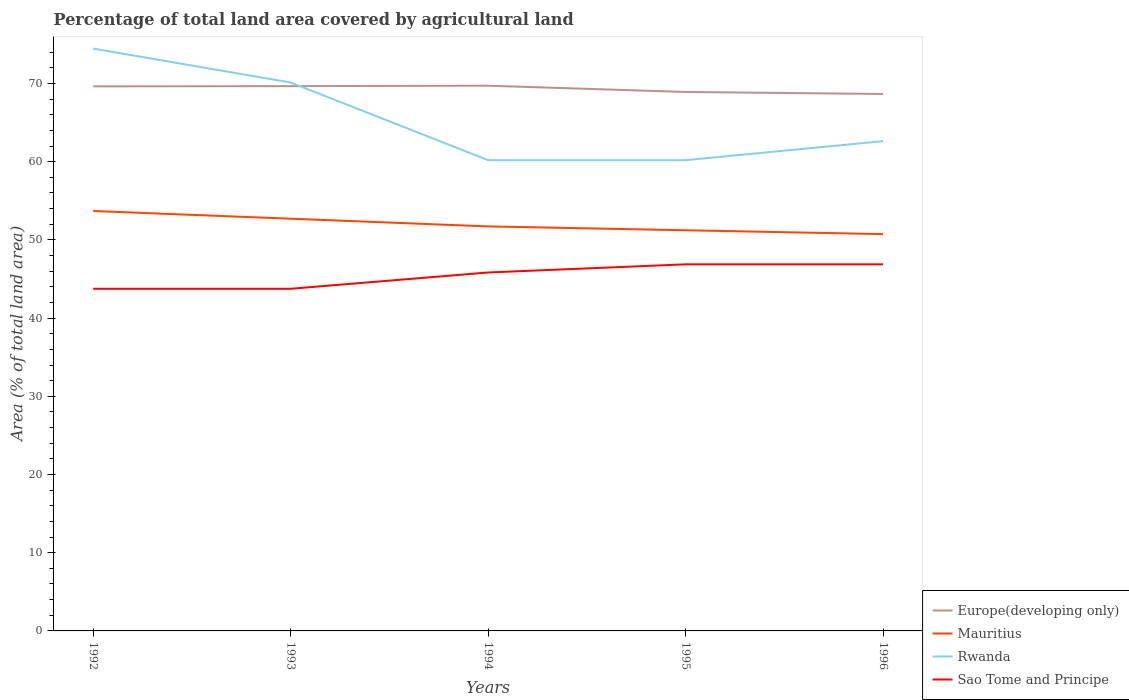Is the number of lines equal to the number of legend labels?
Give a very brief answer. Yes. Across all years, what is the maximum percentage of agricultural land in Mauritius?
Your answer should be very brief. 50.74. What is the total percentage of agricultural land in Rwanda in the graph?
Make the answer very short. 9.93. What is the difference between the highest and the second highest percentage of agricultural land in Mauritius?
Provide a short and direct response. 2.96. What is the difference between the highest and the lowest percentage of agricultural land in Sao Tome and Principe?
Offer a very short reply. 3. What is the difference between two consecutive major ticks on the Y-axis?
Offer a very short reply. 10. Are the values on the major ticks of Y-axis written in scientific E-notation?
Give a very brief answer. No. Does the graph contain any zero values?
Ensure brevity in your answer.  No. Does the graph contain grids?
Offer a very short reply. No. How many legend labels are there?
Your answer should be very brief. 4. What is the title of the graph?
Your answer should be very brief. Percentage of total land area covered by agricultural land. Does "Germany" appear as one of the legend labels in the graph?
Keep it short and to the point. No. What is the label or title of the X-axis?
Provide a short and direct response. Years. What is the label or title of the Y-axis?
Ensure brevity in your answer.  Area (% of total land area). What is the Area (% of total land area) of Europe(developing only) in 1992?
Provide a short and direct response. 69.63. What is the Area (% of total land area) in Mauritius in 1992?
Offer a terse response. 53.69. What is the Area (% of total land area) in Rwanda in 1992?
Make the answer very short. 74.46. What is the Area (% of total land area) in Sao Tome and Principe in 1992?
Give a very brief answer. 43.75. What is the Area (% of total land area) of Europe(developing only) in 1993?
Keep it short and to the point. 69.66. What is the Area (% of total land area) of Mauritius in 1993?
Offer a terse response. 52.71. What is the Area (% of total land area) of Rwanda in 1993?
Offer a terse response. 70.13. What is the Area (% of total land area) of Sao Tome and Principe in 1993?
Give a very brief answer. 43.75. What is the Area (% of total land area) of Europe(developing only) in 1994?
Provide a short and direct response. 69.72. What is the Area (% of total land area) in Mauritius in 1994?
Provide a short and direct response. 51.72. What is the Area (% of total land area) of Rwanda in 1994?
Offer a terse response. 60.19. What is the Area (% of total land area) in Sao Tome and Principe in 1994?
Make the answer very short. 45.83. What is the Area (% of total land area) of Europe(developing only) in 1995?
Provide a succinct answer. 68.92. What is the Area (% of total land area) of Mauritius in 1995?
Your response must be concise. 51.23. What is the Area (% of total land area) in Rwanda in 1995?
Keep it short and to the point. 60.19. What is the Area (% of total land area) in Sao Tome and Principe in 1995?
Your answer should be compact. 46.88. What is the Area (% of total land area) in Europe(developing only) in 1996?
Keep it short and to the point. 68.66. What is the Area (% of total land area) in Mauritius in 1996?
Provide a succinct answer. 50.74. What is the Area (% of total land area) of Rwanda in 1996?
Offer a terse response. 62.63. What is the Area (% of total land area) in Sao Tome and Principe in 1996?
Provide a succinct answer. 46.88. Across all years, what is the maximum Area (% of total land area) of Europe(developing only)?
Provide a short and direct response. 69.72. Across all years, what is the maximum Area (% of total land area) in Mauritius?
Give a very brief answer. 53.69. Across all years, what is the maximum Area (% of total land area) in Rwanda?
Give a very brief answer. 74.46. Across all years, what is the maximum Area (% of total land area) in Sao Tome and Principe?
Your answer should be very brief. 46.88. Across all years, what is the minimum Area (% of total land area) in Europe(developing only)?
Ensure brevity in your answer.  68.66. Across all years, what is the minimum Area (% of total land area) of Mauritius?
Keep it short and to the point. 50.74. Across all years, what is the minimum Area (% of total land area) in Rwanda?
Your answer should be very brief. 60.19. Across all years, what is the minimum Area (% of total land area) in Sao Tome and Principe?
Offer a terse response. 43.75. What is the total Area (% of total land area) of Europe(developing only) in the graph?
Provide a succinct answer. 346.58. What is the total Area (% of total land area) of Mauritius in the graph?
Provide a short and direct response. 260.1. What is the total Area (% of total land area) of Rwanda in the graph?
Your answer should be compact. 327.6. What is the total Area (% of total land area) of Sao Tome and Principe in the graph?
Provide a succinct answer. 227.08. What is the difference between the Area (% of total land area) in Europe(developing only) in 1992 and that in 1993?
Give a very brief answer. -0.03. What is the difference between the Area (% of total land area) of Mauritius in 1992 and that in 1993?
Provide a succinct answer. 0.99. What is the difference between the Area (% of total land area) in Rwanda in 1992 and that in 1993?
Offer a very short reply. 4.34. What is the difference between the Area (% of total land area) in Europe(developing only) in 1992 and that in 1994?
Provide a succinct answer. -0.08. What is the difference between the Area (% of total land area) of Mauritius in 1992 and that in 1994?
Your answer should be very brief. 1.97. What is the difference between the Area (% of total land area) of Rwanda in 1992 and that in 1994?
Offer a terse response. 14.27. What is the difference between the Area (% of total land area) in Sao Tome and Principe in 1992 and that in 1994?
Give a very brief answer. -2.08. What is the difference between the Area (% of total land area) in Europe(developing only) in 1992 and that in 1995?
Make the answer very short. 0.72. What is the difference between the Area (% of total land area) in Mauritius in 1992 and that in 1995?
Give a very brief answer. 2.46. What is the difference between the Area (% of total land area) of Rwanda in 1992 and that in 1995?
Your response must be concise. 14.27. What is the difference between the Area (% of total land area) in Sao Tome and Principe in 1992 and that in 1995?
Keep it short and to the point. -3.12. What is the difference between the Area (% of total land area) of Mauritius in 1992 and that in 1996?
Offer a very short reply. 2.96. What is the difference between the Area (% of total land area) of Rwanda in 1992 and that in 1996?
Your answer should be compact. 11.84. What is the difference between the Area (% of total land area) in Sao Tome and Principe in 1992 and that in 1996?
Your answer should be compact. -3.12. What is the difference between the Area (% of total land area) of Europe(developing only) in 1993 and that in 1994?
Provide a short and direct response. -0.05. What is the difference between the Area (% of total land area) in Mauritius in 1993 and that in 1994?
Ensure brevity in your answer.  0.99. What is the difference between the Area (% of total land area) in Rwanda in 1993 and that in 1994?
Keep it short and to the point. 9.93. What is the difference between the Area (% of total land area) in Sao Tome and Principe in 1993 and that in 1994?
Your answer should be very brief. -2.08. What is the difference between the Area (% of total land area) in Europe(developing only) in 1993 and that in 1995?
Provide a short and direct response. 0.75. What is the difference between the Area (% of total land area) of Mauritius in 1993 and that in 1995?
Ensure brevity in your answer.  1.48. What is the difference between the Area (% of total land area) of Rwanda in 1993 and that in 1995?
Your answer should be very brief. 9.93. What is the difference between the Area (% of total land area) of Sao Tome and Principe in 1993 and that in 1995?
Your answer should be compact. -3.12. What is the difference between the Area (% of total land area) of Europe(developing only) in 1993 and that in 1996?
Offer a very short reply. 1.01. What is the difference between the Area (% of total land area) in Mauritius in 1993 and that in 1996?
Make the answer very short. 1.97. What is the difference between the Area (% of total land area) in Rwanda in 1993 and that in 1996?
Your answer should be compact. 7.5. What is the difference between the Area (% of total land area) in Sao Tome and Principe in 1993 and that in 1996?
Your answer should be very brief. -3.12. What is the difference between the Area (% of total land area) of Europe(developing only) in 1994 and that in 1995?
Provide a short and direct response. 0.8. What is the difference between the Area (% of total land area) in Mauritius in 1994 and that in 1995?
Your response must be concise. 0.49. What is the difference between the Area (% of total land area) of Rwanda in 1994 and that in 1995?
Offer a very short reply. 0. What is the difference between the Area (% of total land area) in Sao Tome and Principe in 1994 and that in 1995?
Your answer should be very brief. -1.04. What is the difference between the Area (% of total land area) of Europe(developing only) in 1994 and that in 1996?
Give a very brief answer. 1.06. What is the difference between the Area (% of total land area) in Mauritius in 1994 and that in 1996?
Make the answer very short. 0.99. What is the difference between the Area (% of total land area) in Rwanda in 1994 and that in 1996?
Offer a very short reply. -2.43. What is the difference between the Area (% of total land area) in Sao Tome and Principe in 1994 and that in 1996?
Offer a very short reply. -1.04. What is the difference between the Area (% of total land area) in Europe(developing only) in 1995 and that in 1996?
Provide a succinct answer. 0.26. What is the difference between the Area (% of total land area) of Mauritius in 1995 and that in 1996?
Offer a terse response. 0.49. What is the difference between the Area (% of total land area) in Rwanda in 1995 and that in 1996?
Make the answer very short. -2.43. What is the difference between the Area (% of total land area) in Europe(developing only) in 1992 and the Area (% of total land area) in Mauritius in 1993?
Your answer should be very brief. 16.92. What is the difference between the Area (% of total land area) in Europe(developing only) in 1992 and the Area (% of total land area) in Rwanda in 1993?
Your answer should be compact. -0.49. What is the difference between the Area (% of total land area) in Europe(developing only) in 1992 and the Area (% of total land area) in Sao Tome and Principe in 1993?
Give a very brief answer. 25.88. What is the difference between the Area (% of total land area) in Mauritius in 1992 and the Area (% of total land area) in Rwanda in 1993?
Keep it short and to the point. -16.43. What is the difference between the Area (% of total land area) of Mauritius in 1992 and the Area (% of total land area) of Sao Tome and Principe in 1993?
Provide a succinct answer. 9.94. What is the difference between the Area (% of total land area) of Rwanda in 1992 and the Area (% of total land area) of Sao Tome and Principe in 1993?
Keep it short and to the point. 30.71. What is the difference between the Area (% of total land area) in Europe(developing only) in 1992 and the Area (% of total land area) in Mauritius in 1994?
Your answer should be compact. 17.91. What is the difference between the Area (% of total land area) of Europe(developing only) in 1992 and the Area (% of total land area) of Rwanda in 1994?
Offer a very short reply. 9.44. What is the difference between the Area (% of total land area) in Europe(developing only) in 1992 and the Area (% of total land area) in Sao Tome and Principe in 1994?
Give a very brief answer. 23.8. What is the difference between the Area (% of total land area) of Mauritius in 1992 and the Area (% of total land area) of Sao Tome and Principe in 1994?
Give a very brief answer. 7.86. What is the difference between the Area (% of total land area) in Rwanda in 1992 and the Area (% of total land area) in Sao Tome and Principe in 1994?
Make the answer very short. 28.63. What is the difference between the Area (% of total land area) of Europe(developing only) in 1992 and the Area (% of total land area) of Mauritius in 1995?
Offer a very short reply. 18.4. What is the difference between the Area (% of total land area) in Europe(developing only) in 1992 and the Area (% of total land area) in Rwanda in 1995?
Your answer should be very brief. 9.44. What is the difference between the Area (% of total land area) of Europe(developing only) in 1992 and the Area (% of total land area) of Sao Tome and Principe in 1995?
Your answer should be compact. 22.76. What is the difference between the Area (% of total land area) in Mauritius in 1992 and the Area (% of total land area) in Sao Tome and Principe in 1995?
Make the answer very short. 6.82. What is the difference between the Area (% of total land area) in Rwanda in 1992 and the Area (% of total land area) in Sao Tome and Principe in 1995?
Provide a succinct answer. 27.59. What is the difference between the Area (% of total land area) of Europe(developing only) in 1992 and the Area (% of total land area) of Mauritius in 1996?
Ensure brevity in your answer.  18.89. What is the difference between the Area (% of total land area) in Europe(developing only) in 1992 and the Area (% of total land area) in Rwanda in 1996?
Offer a terse response. 7.01. What is the difference between the Area (% of total land area) in Europe(developing only) in 1992 and the Area (% of total land area) in Sao Tome and Principe in 1996?
Offer a terse response. 22.76. What is the difference between the Area (% of total land area) of Mauritius in 1992 and the Area (% of total land area) of Rwanda in 1996?
Ensure brevity in your answer.  -8.93. What is the difference between the Area (% of total land area) of Mauritius in 1992 and the Area (% of total land area) of Sao Tome and Principe in 1996?
Give a very brief answer. 6.82. What is the difference between the Area (% of total land area) in Rwanda in 1992 and the Area (% of total land area) in Sao Tome and Principe in 1996?
Offer a very short reply. 27.59. What is the difference between the Area (% of total land area) of Europe(developing only) in 1993 and the Area (% of total land area) of Mauritius in 1994?
Provide a short and direct response. 17.94. What is the difference between the Area (% of total land area) of Europe(developing only) in 1993 and the Area (% of total land area) of Rwanda in 1994?
Your answer should be very brief. 9.47. What is the difference between the Area (% of total land area) in Europe(developing only) in 1993 and the Area (% of total land area) in Sao Tome and Principe in 1994?
Your answer should be very brief. 23.83. What is the difference between the Area (% of total land area) in Mauritius in 1993 and the Area (% of total land area) in Rwanda in 1994?
Offer a terse response. -7.49. What is the difference between the Area (% of total land area) in Mauritius in 1993 and the Area (% of total land area) in Sao Tome and Principe in 1994?
Your answer should be very brief. 6.88. What is the difference between the Area (% of total land area) of Rwanda in 1993 and the Area (% of total land area) of Sao Tome and Principe in 1994?
Your answer should be very brief. 24.29. What is the difference between the Area (% of total land area) in Europe(developing only) in 1993 and the Area (% of total land area) in Mauritius in 1995?
Your answer should be very brief. 18.43. What is the difference between the Area (% of total land area) in Europe(developing only) in 1993 and the Area (% of total land area) in Rwanda in 1995?
Offer a terse response. 9.47. What is the difference between the Area (% of total land area) in Europe(developing only) in 1993 and the Area (% of total land area) in Sao Tome and Principe in 1995?
Offer a very short reply. 22.79. What is the difference between the Area (% of total land area) of Mauritius in 1993 and the Area (% of total land area) of Rwanda in 1995?
Make the answer very short. -7.49. What is the difference between the Area (% of total land area) of Mauritius in 1993 and the Area (% of total land area) of Sao Tome and Principe in 1995?
Your answer should be very brief. 5.83. What is the difference between the Area (% of total land area) of Rwanda in 1993 and the Area (% of total land area) of Sao Tome and Principe in 1995?
Keep it short and to the point. 23.25. What is the difference between the Area (% of total land area) in Europe(developing only) in 1993 and the Area (% of total land area) in Mauritius in 1996?
Keep it short and to the point. 18.92. What is the difference between the Area (% of total land area) in Europe(developing only) in 1993 and the Area (% of total land area) in Rwanda in 1996?
Provide a short and direct response. 7.04. What is the difference between the Area (% of total land area) in Europe(developing only) in 1993 and the Area (% of total land area) in Sao Tome and Principe in 1996?
Give a very brief answer. 22.79. What is the difference between the Area (% of total land area) of Mauritius in 1993 and the Area (% of total land area) of Rwanda in 1996?
Ensure brevity in your answer.  -9.92. What is the difference between the Area (% of total land area) of Mauritius in 1993 and the Area (% of total land area) of Sao Tome and Principe in 1996?
Offer a terse response. 5.83. What is the difference between the Area (% of total land area) in Rwanda in 1993 and the Area (% of total land area) in Sao Tome and Principe in 1996?
Keep it short and to the point. 23.25. What is the difference between the Area (% of total land area) in Europe(developing only) in 1994 and the Area (% of total land area) in Mauritius in 1995?
Offer a very short reply. 18.48. What is the difference between the Area (% of total land area) of Europe(developing only) in 1994 and the Area (% of total land area) of Rwanda in 1995?
Give a very brief answer. 9.52. What is the difference between the Area (% of total land area) of Europe(developing only) in 1994 and the Area (% of total land area) of Sao Tome and Principe in 1995?
Offer a very short reply. 22.84. What is the difference between the Area (% of total land area) of Mauritius in 1994 and the Area (% of total land area) of Rwanda in 1995?
Offer a terse response. -8.47. What is the difference between the Area (% of total land area) of Mauritius in 1994 and the Area (% of total land area) of Sao Tome and Principe in 1995?
Your answer should be compact. 4.85. What is the difference between the Area (% of total land area) in Rwanda in 1994 and the Area (% of total land area) in Sao Tome and Principe in 1995?
Offer a terse response. 13.32. What is the difference between the Area (% of total land area) of Europe(developing only) in 1994 and the Area (% of total land area) of Mauritius in 1996?
Ensure brevity in your answer.  18.98. What is the difference between the Area (% of total land area) of Europe(developing only) in 1994 and the Area (% of total land area) of Rwanda in 1996?
Provide a short and direct response. 7.09. What is the difference between the Area (% of total land area) of Europe(developing only) in 1994 and the Area (% of total land area) of Sao Tome and Principe in 1996?
Make the answer very short. 22.84. What is the difference between the Area (% of total land area) of Mauritius in 1994 and the Area (% of total land area) of Rwanda in 1996?
Keep it short and to the point. -10.9. What is the difference between the Area (% of total land area) in Mauritius in 1994 and the Area (% of total land area) in Sao Tome and Principe in 1996?
Offer a very short reply. 4.85. What is the difference between the Area (% of total land area) in Rwanda in 1994 and the Area (% of total land area) in Sao Tome and Principe in 1996?
Give a very brief answer. 13.32. What is the difference between the Area (% of total land area) in Europe(developing only) in 1995 and the Area (% of total land area) in Mauritius in 1996?
Offer a very short reply. 18.18. What is the difference between the Area (% of total land area) in Europe(developing only) in 1995 and the Area (% of total land area) in Rwanda in 1996?
Your answer should be very brief. 6.29. What is the difference between the Area (% of total land area) of Europe(developing only) in 1995 and the Area (% of total land area) of Sao Tome and Principe in 1996?
Your response must be concise. 22.04. What is the difference between the Area (% of total land area) in Mauritius in 1995 and the Area (% of total land area) in Rwanda in 1996?
Make the answer very short. -11.4. What is the difference between the Area (% of total land area) of Mauritius in 1995 and the Area (% of total land area) of Sao Tome and Principe in 1996?
Keep it short and to the point. 4.36. What is the difference between the Area (% of total land area) of Rwanda in 1995 and the Area (% of total land area) of Sao Tome and Principe in 1996?
Offer a terse response. 13.32. What is the average Area (% of total land area) in Europe(developing only) per year?
Keep it short and to the point. 69.32. What is the average Area (% of total land area) in Mauritius per year?
Make the answer very short. 52.02. What is the average Area (% of total land area) in Rwanda per year?
Your answer should be very brief. 65.52. What is the average Area (% of total land area) in Sao Tome and Principe per year?
Provide a succinct answer. 45.42. In the year 1992, what is the difference between the Area (% of total land area) in Europe(developing only) and Area (% of total land area) in Mauritius?
Give a very brief answer. 15.94. In the year 1992, what is the difference between the Area (% of total land area) of Europe(developing only) and Area (% of total land area) of Rwanda?
Your answer should be very brief. -4.83. In the year 1992, what is the difference between the Area (% of total land area) of Europe(developing only) and Area (% of total land area) of Sao Tome and Principe?
Your response must be concise. 25.88. In the year 1992, what is the difference between the Area (% of total land area) of Mauritius and Area (% of total land area) of Rwanda?
Make the answer very short. -20.77. In the year 1992, what is the difference between the Area (% of total land area) of Mauritius and Area (% of total land area) of Sao Tome and Principe?
Provide a short and direct response. 9.94. In the year 1992, what is the difference between the Area (% of total land area) in Rwanda and Area (% of total land area) in Sao Tome and Principe?
Offer a terse response. 30.71. In the year 1993, what is the difference between the Area (% of total land area) in Europe(developing only) and Area (% of total land area) in Mauritius?
Ensure brevity in your answer.  16.95. In the year 1993, what is the difference between the Area (% of total land area) in Europe(developing only) and Area (% of total land area) in Rwanda?
Provide a succinct answer. -0.46. In the year 1993, what is the difference between the Area (% of total land area) in Europe(developing only) and Area (% of total land area) in Sao Tome and Principe?
Your answer should be very brief. 25.91. In the year 1993, what is the difference between the Area (% of total land area) of Mauritius and Area (% of total land area) of Rwanda?
Offer a very short reply. -17.42. In the year 1993, what is the difference between the Area (% of total land area) in Mauritius and Area (% of total land area) in Sao Tome and Principe?
Offer a very short reply. 8.96. In the year 1993, what is the difference between the Area (% of total land area) of Rwanda and Area (% of total land area) of Sao Tome and Principe?
Provide a short and direct response. 26.38. In the year 1994, what is the difference between the Area (% of total land area) in Europe(developing only) and Area (% of total land area) in Mauritius?
Ensure brevity in your answer.  17.99. In the year 1994, what is the difference between the Area (% of total land area) of Europe(developing only) and Area (% of total land area) of Rwanda?
Give a very brief answer. 9.52. In the year 1994, what is the difference between the Area (% of total land area) in Europe(developing only) and Area (% of total land area) in Sao Tome and Principe?
Your answer should be compact. 23.88. In the year 1994, what is the difference between the Area (% of total land area) of Mauritius and Area (% of total land area) of Rwanda?
Provide a short and direct response. -8.47. In the year 1994, what is the difference between the Area (% of total land area) of Mauritius and Area (% of total land area) of Sao Tome and Principe?
Offer a terse response. 5.89. In the year 1994, what is the difference between the Area (% of total land area) of Rwanda and Area (% of total land area) of Sao Tome and Principe?
Give a very brief answer. 14.36. In the year 1995, what is the difference between the Area (% of total land area) of Europe(developing only) and Area (% of total land area) of Mauritius?
Make the answer very short. 17.68. In the year 1995, what is the difference between the Area (% of total land area) of Europe(developing only) and Area (% of total land area) of Rwanda?
Keep it short and to the point. 8.72. In the year 1995, what is the difference between the Area (% of total land area) of Europe(developing only) and Area (% of total land area) of Sao Tome and Principe?
Your answer should be very brief. 22.04. In the year 1995, what is the difference between the Area (% of total land area) of Mauritius and Area (% of total land area) of Rwanda?
Keep it short and to the point. -8.96. In the year 1995, what is the difference between the Area (% of total land area) in Mauritius and Area (% of total land area) in Sao Tome and Principe?
Your answer should be compact. 4.36. In the year 1995, what is the difference between the Area (% of total land area) in Rwanda and Area (% of total land area) in Sao Tome and Principe?
Your response must be concise. 13.32. In the year 1996, what is the difference between the Area (% of total land area) in Europe(developing only) and Area (% of total land area) in Mauritius?
Give a very brief answer. 17.92. In the year 1996, what is the difference between the Area (% of total land area) in Europe(developing only) and Area (% of total land area) in Rwanda?
Your answer should be compact. 6.03. In the year 1996, what is the difference between the Area (% of total land area) of Europe(developing only) and Area (% of total land area) of Sao Tome and Principe?
Provide a succinct answer. 21.78. In the year 1996, what is the difference between the Area (% of total land area) of Mauritius and Area (% of total land area) of Rwanda?
Your answer should be compact. -11.89. In the year 1996, what is the difference between the Area (% of total land area) of Mauritius and Area (% of total land area) of Sao Tome and Principe?
Offer a terse response. 3.86. In the year 1996, what is the difference between the Area (% of total land area) in Rwanda and Area (% of total land area) in Sao Tome and Principe?
Keep it short and to the point. 15.75. What is the ratio of the Area (% of total land area) of Europe(developing only) in 1992 to that in 1993?
Make the answer very short. 1. What is the ratio of the Area (% of total land area) of Mauritius in 1992 to that in 1993?
Your answer should be compact. 1.02. What is the ratio of the Area (% of total land area) in Rwanda in 1992 to that in 1993?
Keep it short and to the point. 1.06. What is the ratio of the Area (% of total land area) in Mauritius in 1992 to that in 1994?
Provide a succinct answer. 1.04. What is the ratio of the Area (% of total land area) in Rwanda in 1992 to that in 1994?
Offer a very short reply. 1.24. What is the ratio of the Area (% of total land area) in Sao Tome and Principe in 1992 to that in 1994?
Your answer should be very brief. 0.95. What is the ratio of the Area (% of total land area) in Europe(developing only) in 1992 to that in 1995?
Make the answer very short. 1.01. What is the ratio of the Area (% of total land area) of Mauritius in 1992 to that in 1995?
Ensure brevity in your answer.  1.05. What is the ratio of the Area (% of total land area) of Rwanda in 1992 to that in 1995?
Your answer should be very brief. 1.24. What is the ratio of the Area (% of total land area) in Sao Tome and Principe in 1992 to that in 1995?
Your answer should be very brief. 0.93. What is the ratio of the Area (% of total land area) in Europe(developing only) in 1992 to that in 1996?
Your answer should be compact. 1.01. What is the ratio of the Area (% of total land area) in Mauritius in 1992 to that in 1996?
Offer a very short reply. 1.06. What is the ratio of the Area (% of total land area) of Rwanda in 1992 to that in 1996?
Your answer should be compact. 1.19. What is the ratio of the Area (% of total land area) in Sao Tome and Principe in 1992 to that in 1996?
Keep it short and to the point. 0.93. What is the ratio of the Area (% of total land area) in Mauritius in 1993 to that in 1994?
Ensure brevity in your answer.  1.02. What is the ratio of the Area (% of total land area) of Rwanda in 1993 to that in 1994?
Make the answer very short. 1.17. What is the ratio of the Area (% of total land area) of Sao Tome and Principe in 1993 to that in 1994?
Your response must be concise. 0.95. What is the ratio of the Area (% of total land area) of Europe(developing only) in 1993 to that in 1995?
Keep it short and to the point. 1.01. What is the ratio of the Area (% of total land area) in Mauritius in 1993 to that in 1995?
Offer a terse response. 1.03. What is the ratio of the Area (% of total land area) of Rwanda in 1993 to that in 1995?
Give a very brief answer. 1.17. What is the ratio of the Area (% of total land area) of Sao Tome and Principe in 1993 to that in 1995?
Provide a succinct answer. 0.93. What is the ratio of the Area (% of total land area) in Europe(developing only) in 1993 to that in 1996?
Your response must be concise. 1.01. What is the ratio of the Area (% of total land area) in Mauritius in 1993 to that in 1996?
Your response must be concise. 1.04. What is the ratio of the Area (% of total land area) of Rwanda in 1993 to that in 1996?
Your response must be concise. 1.12. What is the ratio of the Area (% of total land area) in Europe(developing only) in 1994 to that in 1995?
Give a very brief answer. 1.01. What is the ratio of the Area (% of total land area) of Mauritius in 1994 to that in 1995?
Offer a very short reply. 1.01. What is the ratio of the Area (% of total land area) of Rwanda in 1994 to that in 1995?
Keep it short and to the point. 1. What is the ratio of the Area (% of total land area) of Sao Tome and Principe in 1994 to that in 1995?
Offer a very short reply. 0.98. What is the ratio of the Area (% of total land area) in Europe(developing only) in 1994 to that in 1996?
Your answer should be compact. 1.02. What is the ratio of the Area (% of total land area) of Mauritius in 1994 to that in 1996?
Your answer should be compact. 1.02. What is the ratio of the Area (% of total land area) of Rwanda in 1994 to that in 1996?
Your answer should be very brief. 0.96. What is the ratio of the Area (% of total land area) of Sao Tome and Principe in 1994 to that in 1996?
Provide a short and direct response. 0.98. What is the ratio of the Area (% of total land area) of Europe(developing only) in 1995 to that in 1996?
Offer a terse response. 1. What is the ratio of the Area (% of total land area) of Mauritius in 1995 to that in 1996?
Offer a very short reply. 1.01. What is the ratio of the Area (% of total land area) of Rwanda in 1995 to that in 1996?
Provide a short and direct response. 0.96. What is the ratio of the Area (% of total land area) in Sao Tome and Principe in 1995 to that in 1996?
Offer a very short reply. 1. What is the difference between the highest and the second highest Area (% of total land area) of Europe(developing only)?
Offer a terse response. 0.05. What is the difference between the highest and the second highest Area (% of total land area) in Mauritius?
Make the answer very short. 0.99. What is the difference between the highest and the second highest Area (% of total land area) in Rwanda?
Your answer should be compact. 4.34. What is the difference between the highest and the second highest Area (% of total land area) of Sao Tome and Principe?
Offer a very short reply. 0. What is the difference between the highest and the lowest Area (% of total land area) in Europe(developing only)?
Give a very brief answer. 1.06. What is the difference between the highest and the lowest Area (% of total land area) in Mauritius?
Provide a succinct answer. 2.96. What is the difference between the highest and the lowest Area (% of total land area) of Rwanda?
Your answer should be very brief. 14.27. What is the difference between the highest and the lowest Area (% of total land area) of Sao Tome and Principe?
Provide a succinct answer. 3.12. 